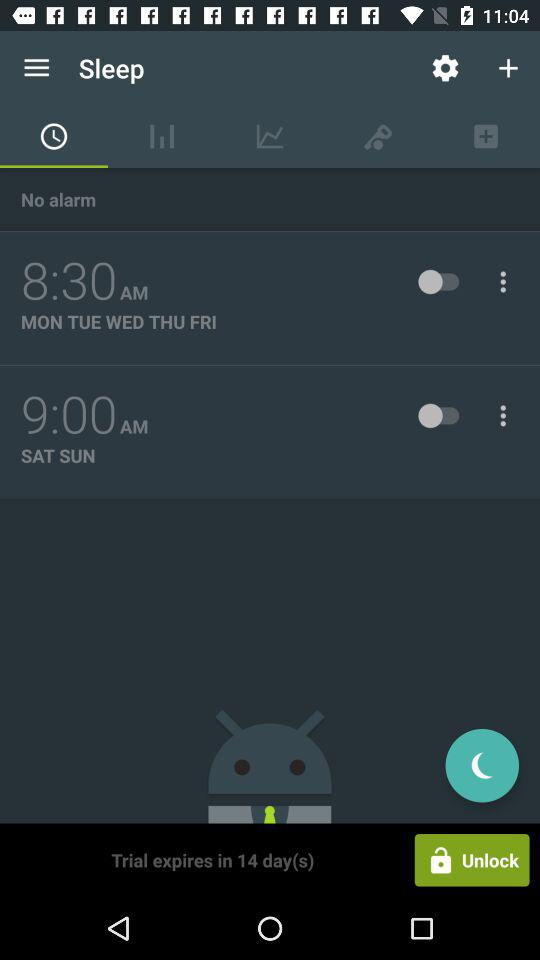What is the status of the 8:30 AM alarm? The status is off. 